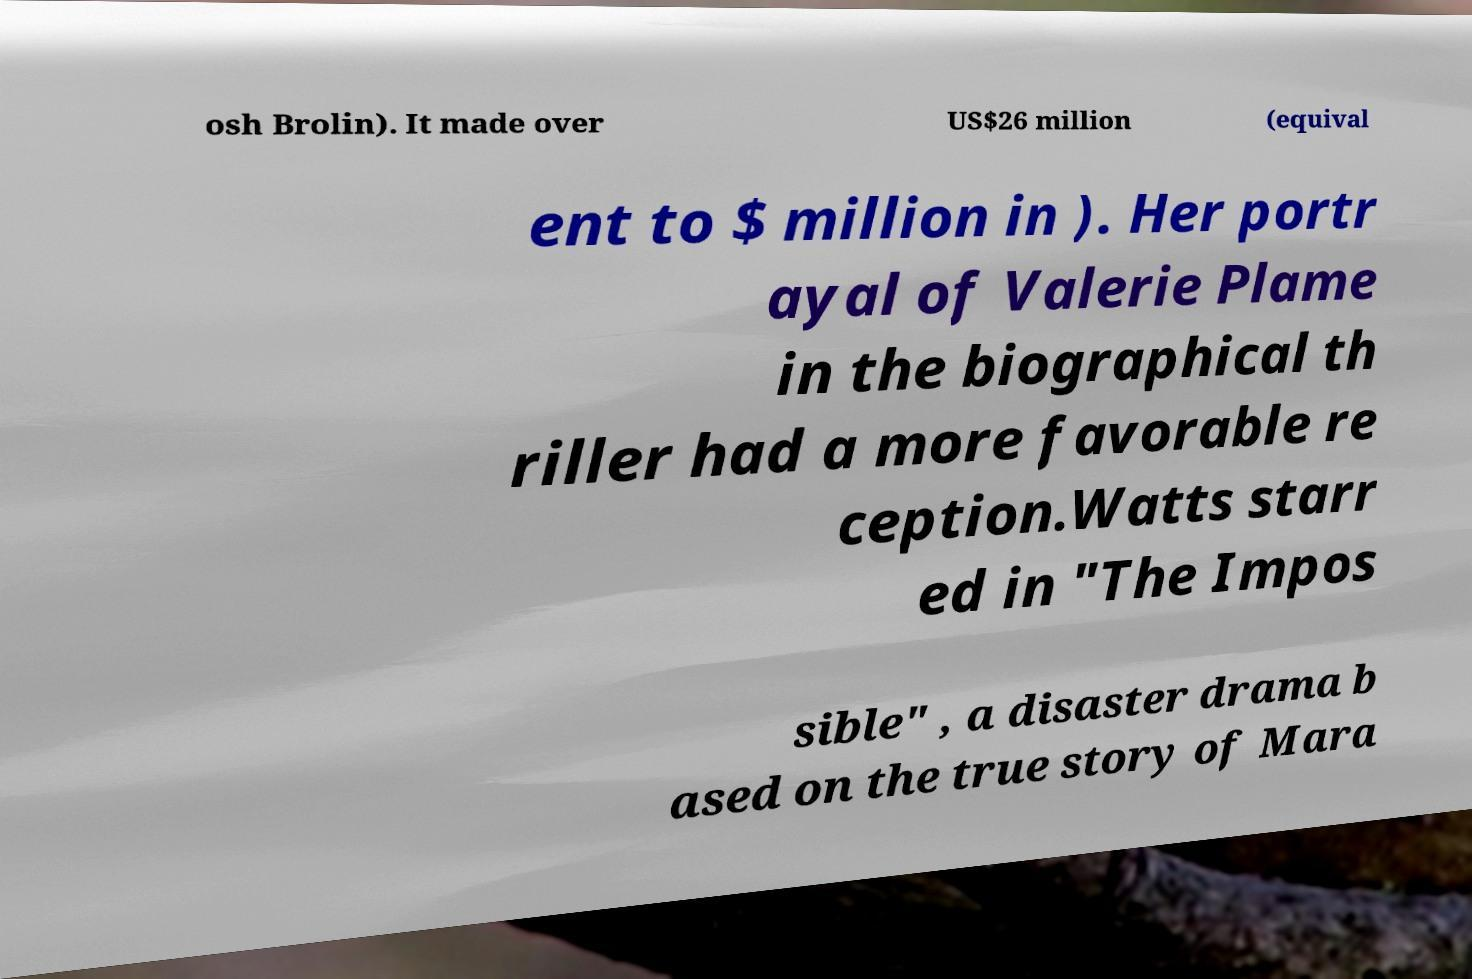What messages or text are displayed in this image? I need them in a readable, typed format. osh Brolin). It made over US$26 million (equival ent to $ million in ). Her portr ayal of Valerie Plame in the biographical th riller had a more favorable re ception.Watts starr ed in "The Impos sible" , a disaster drama b ased on the true story of Mara 